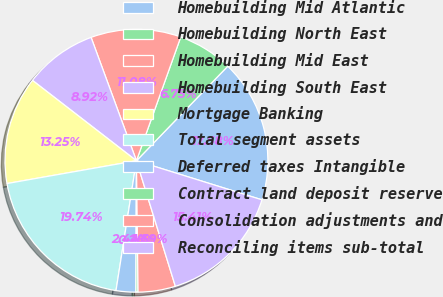<chart> <loc_0><loc_0><loc_500><loc_500><pie_chart><fcel>Homebuilding Mid Atlantic<fcel>Homebuilding North East<fcel>Homebuilding Mid East<fcel>Homebuilding South East<fcel>Mortgage Banking<fcel>Total segment assets<fcel>Deferred taxes Intangible<fcel>Contract land deposit reserve<fcel>Consolidation adjustments and<fcel>Reconciling items sub-total<nl><fcel>17.58%<fcel>6.75%<fcel>11.08%<fcel>8.92%<fcel>13.25%<fcel>19.74%<fcel>2.42%<fcel>0.26%<fcel>4.59%<fcel>15.41%<nl></chart> 